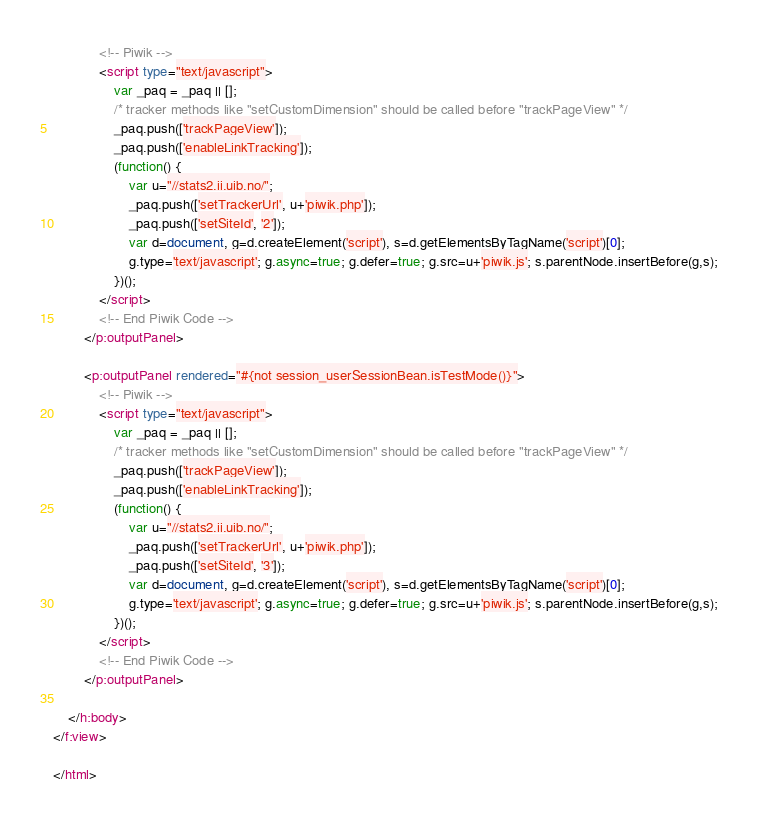Convert code to text. <code><loc_0><loc_0><loc_500><loc_500><_HTML_>            <!-- Piwik -->
            <script type="text/javascript">
                var _paq = _paq || [];
                /* tracker methods like "setCustomDimension" should be called before "trackPageView" */
                _paq.push(['trackPageView']);
                _paq.push(['enableLinkTracking']);
                (function() {
                    var u="//stats2.ii.uib.no/";
                    _paq.push(['setTrackerUrl', u+'piwik.php']);
                    _paq.push(['setSiteId', '2']);
                    var d=document, g=d.createElement('script'), s=d.getElementsByTagName('script')[0];
                    g.type='text/javascript'; g.async=true; g.defer=true; g.src=u+'piwik.js'; s.parentNode.insertBefore(g,s);
                })();
            </script>
            <!-- End Piwik Code -->
        </p:outputPanel>

        <p:outputPanel rendered="#{not session_userSessionBean.isTestMode()}">
            <!-- Piwik -->
            <script type="text/javascript">
                var _paq = _paq || [];
                /* tracker methods like "setCustomDimension" should be called before "trackPageView" */
                _paq.push(['trackPageView']);
                _paq.push(['enableLinkTracking']);
                (function() {
                    var u="//stats2.ii.uib.no/";
                    _paq.push(['setTrackerUrl', u+'piwik.php']);
                    _paq.push(['setSiteId', '3']);
                    var d=document, g=d.createElement('script'), s=d.getElementsByTagName('script')[0];
                    g.type='text/javascript'; g.async=true; g.defer=true; g.src=u+'piwik.js'; s.parentNode.insertBefore(g,s);
                })();
            </script>
            <!-- End Piwik Code -->
        </p:outputPanel>

    </h:body>
</f:view>

</html>


</code> 